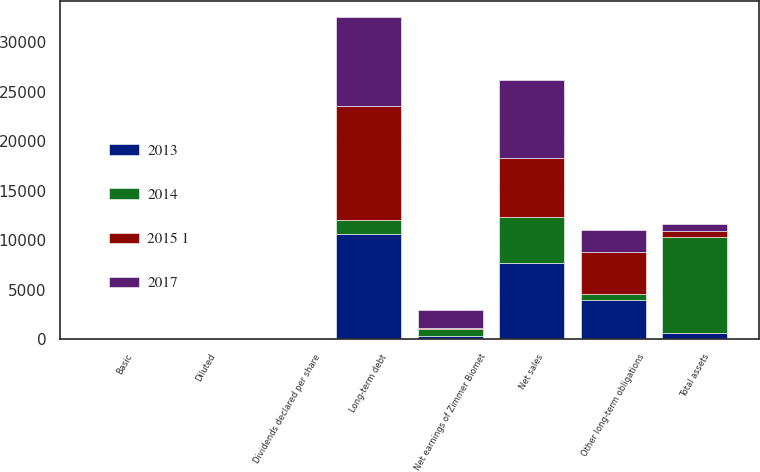Convert chart to OTSL. <chart><loc_0><loc_0><loc_500><loc_500><stacked_bar_chart><ecel><fcel>Net sales<fcel>Net earnings of Zimmer Biomet<fcel>Basic<fcel>Diluted<fcel>Dividends declared per share<fcel>Total assets<fcel>Long-term debt<fcel>Other long-term obligations<nl><fcel>2017<fcel>7824.1<fcel>1813.8<fcel>8.98<fcel>8.9<fcel>0.96<fcel>656.8<fcel>8917.5<fcel>2291.3<nl><fcel>2013<fcel>7683.9<fcel>305.9<fcel>1.53<fcel>1.51<fcel>0.96<fcel>656.8<fcel>10665.8<fcel>3967.2<nl><fcel>2015 1<fcel>5997.8<fcel>147<fcel>0.78<fcel>0.77<fcel>0.88<fcel>656.8<fcel>11497.4<fcel>4155.9<nl><fcel>2014<fcel>4673.3<fcel>720.3<fcel>4.26<fcel>4.2<fcel>0.88<fcel>9658<fcel>1425.5<fcel>656.8<nl></chart> 